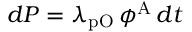<formula> <loc_0><loc_0><loc_500><loc_500>d P = \lambda _ { p O } \, \phi ^ { A } \, d t</formula> 